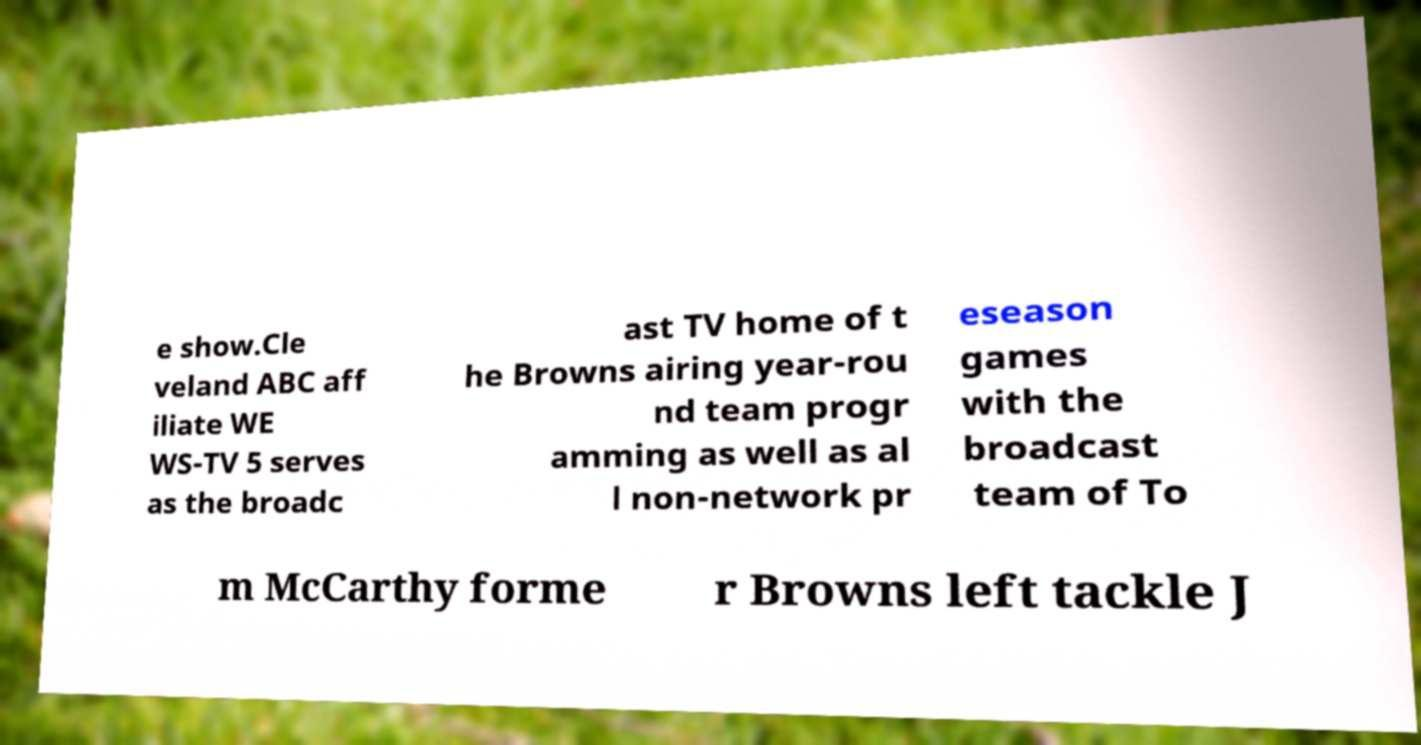Please identify and transcribe the text found in this image. e show.Cle veland ABC aff iliate WE WS-TV 5 serves as the broadc ast TV home of t he Browns airing year-rou nd team progr amming as well as al l non-network pr eseason games with the broadcast team of To m McCarthy forme r Browns left tackle J 